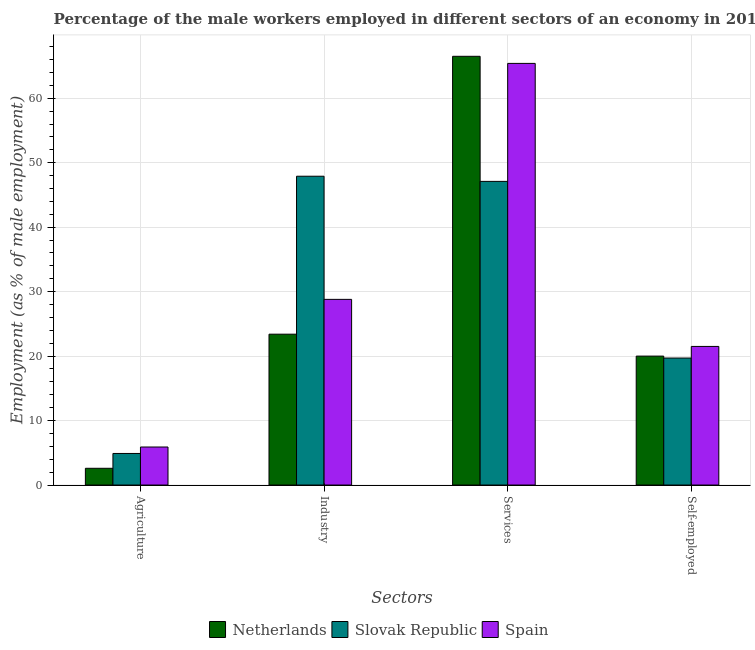How many bars are there on the 4th tick from the left?
Provide a short and direct response. 3. How many bars are there on the 4th tick from the right?
Keep it short and to the point. 3. What is the label of the 4th group of bars from the left?
Offer a terse response. Self-employed. What is the percentage of self employed male workers in Slovak Republic?
Your answer should be compact. 19.7. Across all countries, what is the maximum percentage of male workers in agriculture?
Provide a short and direct response. 5.9. Across all countries, what is the minimum percentage of male workers in agriculture?
Your answer should be very brief. 2.6. In which country was the percentage of male workers in agriculture maximum?
Provide a short and direct response. Spain. In which country was the percentage of male workers in services minimum?
Give a very brief answer. Slovak Republic. What is the total percentage of male workers in services in the graph?
Provide a short and direct response. 179. What is the difference between the percentage of male workers in services in Slovak Republic and that in Netherlands?
Your response must be concise. -19.4. What is the difference between the percentage of male workers in agriculture in Spain and the percentage of male workers in industry in Slovak Republic?
Offer a very short reply. -42. What is the average percentage of male workers in services per country?
Make the answer very short. 59.67. What is the difference between the percentage of male workers in services and percentage of self employed male workers in Spain?
Your answer should be very brief. 43.9. What is the ratio of the percentage of male workers in industry in Netherlands to that in Spain?
Keep it short and to the point. 0.81. Is the percentage of male workers in agriculture in Spain less than that in Slovak Republic?
Your response must be concise. No. What is the difference between the highest and the second highest percentage of self employed male workers?
Your answer should be very brief. 1.5. What is the difference between the highest and the lowest percentage of male workers in agriculture?
Make the answer very short. 3.3. What does the 2nd bar from the left in Industry represents?
Keep it short and to the point. Slovak Republic. What does the 2nd bar from the right in Services represents?
Offer a terse response. Slovak Republic. Is it the case that in every country, the sum of the percentage of male workers in agriculture and percentage of male workers in industry is greater than the percentage of male workers in services?
Offer a terse response. No. How many bars are there?
Provide a short and direct response. 12. Does the graph contain any zero values?
Offer a terse response. No. How are the legend labels stacked?
Offer a very short reply. Horizontal. What is the title of the graph?
Ensure brevity in your answer.  Percentage of the male workers employed in different sectors of an economy in 2014. Does "Guam" appear as one of the legend labels in the graph?
Make the answer very short. No. What is the label or title of the X-axis?
Make the answer very short. Sectors. What is the label or title of the Y-axis?
Your answer should be very brief. Employment (as % of male employment). What is the Employment (as % of male employment) of Netherlands in Agriculture?
Provide a succinct answer. 2.6. What is the Employment (as % of male employment) of Slovak Republic in Agriculture?
Your answer should be very brief. 4.9. What is the Employment (as % of male employment) of Spain in Agriculture?
Keep it short and to the point. 5.9. What is the Employment (as % of male employment) in Netherlands in Industry?
Your answer should be compact. 23.4. What is the Employment (as % of male employment) of Slovak Republic in Industry?
Provide a short and direct response. 47.9. What is the Employment (as % of male employment) in Spain in Industry?
Provide a succinct answer. 28.8. What is the Employment (as % of male employment) of Netherlands in Services?
Give a very brief answer. 66.5. What is the Employment (as % of male employment) of Slovak Republic in Services?
Give a very brief answer. 47.1. What is the Employment (as % of male employment) of Spain in Services?
Offer a very short reply. 65.4. What is the Employment (as % of male employment) of Netherlands in Self-employed?
Give a very brief answer. 20. What is the Employment (as % of male employment) in Slovak Republic in Self-employed?
Your response must be concise. 19.7. What is the Employment (as % of male employment) of Spain in Self-employed?
Your response must be concise. 21.5. Across all Sectors, what is the maximum Employment (as % of male employment) in Netherlands?
Make the answer very short. 66.5. Across all Sectors, what is the maximum Employment (as % of male employment) in Slovak Republic?
Your answer should be very brief. 47.9. Across all Sectors, what is the maximum Employment (as % of male employment) in Spain?
Your answer should be very brief. 65.4. Across all Sectors, what is the minimum Employment (as % of male employment) in Netherlands?
Ensure brevity in your answer.  2.6. Across all Sectors, what is the minimum Employment (as % of male employment) of Slovak Republic?
Make the answer very short. 4.9. Across all Sectors, what is the minimum Employment (as % of male employment) of Spain?
Your answer should be very brief. 5.9. What is the total Employment (as % of male employment) of Netherlands in the graph?
Your response must be concise. 112.5. What is the total Employment (as % of male employment) of Slovak Republic in the graph?
Your response must be concise. 119.6. What is the total Employment (as % of male employment) of Spain in the graph?
Your answer should be compact. 121.6. What is the difference between the Employment (as % of male employment) in Netherlands in Agriculture and that in Industry?
Your answer should be compact. -20.8. What is the difference between the Employment (as % of male employment) of Slovak Republic in Agriculture and that in Industry?
Ensure brevity in your answer.  -43. What is the difference between the Employment (as % of male employment) in Spain in Agriculture and that in Industry?
Your response must be concise. -22.9. What is the difference between the Employment (as % of male employment) of Netherlands in Agriculture and that in Services?
Your answer should be very brief. -63.9. What is the difference between the Employment (as % of male employment) of Slovak Republic in Agriculture and that in Services?
Offer a very short reply. -42.2. What is the difference between the Employment (as % of male employment) in Spain in Agriculture and that in Services?
Keep it short and to the point. -59.5. What is the difference between the Employment (as % of male employment) in Netherlands in Agriculture and that in Self-employed?
Your response must be concise. -17.4. What is the difference between the Employment (as % of male employment) of Slovak Republic in Agriculture and that in Self-employed?
Offer a terse response. -14.8. What is the difference between the Employment (as % of male employment) of Spain in Agriculture and that in Self-employed?
Offer a very short reply. -15.6. What is the difference between the Employment (as % of male employment) of Netherlands in Industry and that in Services?
Give a very brief answer. -43.1. What is the difference between the Employment (as % of male employment) in Spain in Industry and that in Services?
Offer a terse response. -36.6. What is the difference between the Employment (as % of male employment) of Slovak Republic in Industry and that in Self-employed?
Offer a terse response. 28.2. What is the difference between the Employment (as % of male employment) in Netherlands in Services and that in Self-employed?
Your answer should be very brief. 46.5. What is the difference between the Employment (as % of male employment) of Slovak Republic in Services and that in Self-employed?
Provide a succinct answer. 27.4. What is the difference between the Employment (as % of male employment) in Spain in Services and that in Self-employed?
Offer a terse response. 43.9. What is the difference between the Employment (as % of male employment) of Netherlands in Agriculture and the Employment (as % of male employment) of Slovak Republic in Industry?
Your response must be concise. -45.3. What is the difference between the Employment (as % of male employment) of Netherlands in Agriculture and the Employment (as % of male employment) of Spain in Industry?
Your answer should be compact. -26.2. What is the difference between the Employment (as % of male employment) of Slovak Republic in Agriculture and the Employment (as % of male employment) of Spain in Industry?
Your response must be concise. -23.9. What is the difference between the Employment (as % of male employment) of Netherlands in Agriculture and the Employment (as % of male employment) of Slovak Republic in Services?
Provide a short and direct response. -44.5. What is the difference between the Employment (as % of male employment) of Netherlands in Agriculture and the Employment (as % of male employment) of Spain in Services?
Your answer should be compact. -62.8. What is the difference between the Employment (as % of male employment) in Slovak Republic in Agriculture and the Employment (as % of male employment) in Spain in Services?
Provide a succinct answer. -60.5. What is the difference between the Employment (as % of male employment) in Netherlands in Agriculture and the Employment (as % of male employment) in Slovak Republic in Self-employed?
Keep it short and to the point. -17.1. What is the difference between the Employment (as % of male employment) of Netherlands in Agriculture and the Employment (as % of male employment) of Spain in Self-employed?
Offer a very short reply. -18.9. What is the difference between the Employment (as % of male employment) in Slovak Republic in Agriculture and the Employment (as % of male employment) in Spain in Self-employed?
Offer a terse response. -16.6. What is the difference between the Employment (as % of male employment) of Netherlands in Industry and the Employment (as % of male employment) of Slovak Republic in Services?
Give a very brief answer. -23.7. What is the difference between the Employment (as % of male employment) in Netherlands in Industry and the Employment (as % of male employment) in Spain in Services?
Give a very brief answer. -42. What is the difference between the Employment (as % of male employment) in Slovak Republic in Industry and the Employment (as % of male employment) in Spain in Services?
Ensure brevity in your answer.  -17.5. What is the difference between the Employment (as % of male employment) in Netherlands in Industry and the Employment (as % of male employment) in Slovak Republic in Self-employed?
Offer a terse response. 3.7. What is the difference between the Employment (as % of male employment) of Netherlands in Industry and the Employment (as % of male employment) of Spain in Self-employed?
Your answer should be very brief. 1.9. What is the difference between the Employment (as % of male employment) in Slovak Republic in Industry and the Employment (as % of male employment) in Spain in Self-employed?
Give a very brief answer. 26.4. What is the difference between the Employment (as % of male employment) in Netherlands in Services and the Employment (as % of male employment) in Slovak Republic in Self-employed?
Your response must be concise. 46.8. What is the difference between the Employment (as % of male employment) of Netherlands in Services and the Employment (as % of male employment) of Spain in Self-employed?
Your answer should be compact. 45. What is the difference between the Employment (as % of male employment) in Slovak Republic in Services and the Employment (as % of male employment) in Spain in Self-employed?
Offer a terse response. 25.6. What is the average Employment (as % of male employment) in Netherlands per Sectors?
Offer a terse response. 28.12. What is the average Employment (as % of male employment) in Slovak Republic per Sectors?
Make the answer very short. 29.9. What is the average Employment (as % of male employment) in Spain per Sectors?
Your response must be concise. 30.4. What is the difference between the Employment (as % of male employment) in Slovak Republic and Employment (as % of male employment) in Spain in Agriculture?
Keep it short and to the point. -1. What is the difference between the Employment (as % of male employment) in Netherlands and Employment (as % of male employment) in Slovak Republic in Industry?
Keep it short and to the point. -24.5. What is the difference between the Employment (as % of male employment) of Netherlands and Employment (as % of male employment) of Spain in Industry?
Provide a short and direct response. -5.4. What is the difference between the Employment (as % of male employment) in Slovak Republic and Employment (as % of male employment) in Spain in Services?
Your response must be concise. -18.3. What is the difference between the Employment (as % of male employment) in Netherlands and Employment (as % of male employment) in Slovak Republic in Self-employed?
Ensure brevity in your answer.  0.3. What is the difference between the Employment (as % of male employment) of Netherlands and Employment (as % of male employment) of Spain in Self-employed?
Provide a short and direct response. -1.5. What is the difference between the Employment (as % of male employment) of Slovak Republic and Employment (as % of male employment) of Spain in Self-employed?
Your response must be concise. -1.8. What is the ratio of the Employment (as % of male employment) in Netherlands in Agriculture to that in Industry?
Your answer should be compact. 0.11. What is the ratio of the Employment (as % of male employment) in Slovak Republic in Agriculture to that in Industry?
Provide a succinct answer. 0.1. What is the ratio of the Employment (as % of male employment) of Spain in Agriculture to that in Industry?
Your response must be concise. 0.2. What is the ratio of the Employment (as % of male employment) in Netherlands in Agriculture to that in Services?
Make the answer very short. 0.04. What is the ratio of the Employment (as % of male employment) of Slovak Republic in Agriculture to that in Services?
Ensure brevity in your answer.  0.1. What is the ratio of the Employment (as % of male employment) in Spain in Agriculture to that in Services?
Your answer should be very brief. 0.09. What is the ratio of the Employment (as % of male employment) of Netherlands in Agriculture to that in Self-employed?
Your response must be concise. 0.13. What is the ratio of the Employment (as % of male employment) in Slovak Republic in Agriculture to that in Self-employed?
Offer a very short reply. 0.25. What is the ratio of the Employment (as % of male employment) in Spain in Agriculture to that in Self-employed?
Your answer should be compact. 0.27. What is the ratio of the Employment (as % of male employment) in Netherlands in Industry to that in Services?
Offer a very short reply. 0.35. What is the ratio of the Employment (as % of male employment) of Spain in Industry to that in Services?
Keep it short and to the point. 0.44. What is the ratio of the Employment (as % of male employment) of Netherlands in Industry to that in Self-employed?
Provide a succinct answer. 1.17. What is the ratio of the Employment (as % of male employment) in Slovak Republic in Industry to that in Self-employed?
Your response must be concise. 2.43. What is the ratio of the Employment (as % of male employment) of Spain in Industry to that in Self-employed?
Provide a short and direct response. 1.34. What is the ratio of the Employment (as % of male employment) of Netherlands in Services to that in Self-employed?
Give a very brief answer. 3.33. What is the ratio of the Employment (as % of male employment) of Slovak Republic in Services to that in Self-employed?
Your answer should be very brief. 2.39. What is the ratio of the Employment (as % of male employment) in Spain in Services to that in Self-employed?
Keep it short and to the point. 3.04. What is the difference between the highest and the second highest Employment (as % of male employment) in Netherlands?
Provide a succinct answer. 43.1. What is the difference between the highest and the second highest Employment (as % of male employment) of Spain?
Your answer should be compact. 36.6. What is the difference between the highest and the lowest Employment (as % of male employment) in Netherlands?
Offer a very short reply. 63.9. What is the difference between the highest and the lowest Employment (as % of male employment) of Slovak Republic?
Your answer should be compact. 43. What is the difference between the highest and the lowest Employment (as % of male employment) in Spain?
Keep it short and to the point. 59.5. 